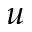<formula> <loc_0><loc_0><loc_500><loc_500>u</formula> 